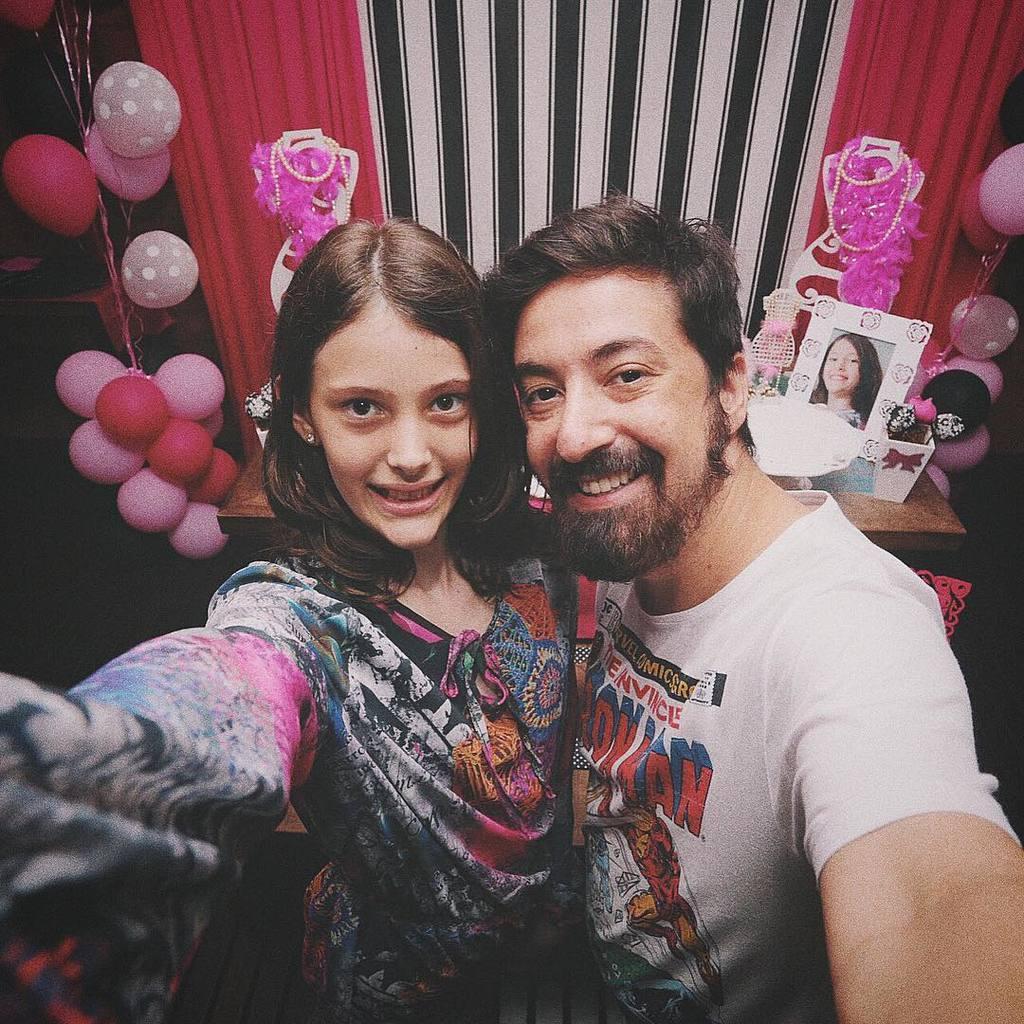Please provide a concise description of this image. In this image, we can see a man and a lady and in the background, there are balloons, a curtain, some decor, a frame and some other objects are on the table. 